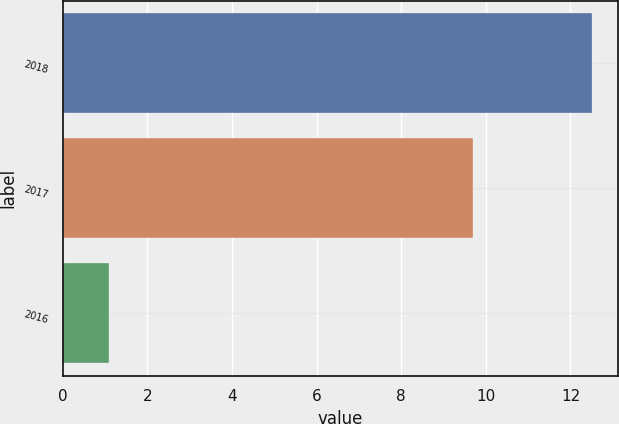Convert chart to OTSL. <chart><loc_0><loc_0><loc_500><loc_500><bar_chart><fcel>2018<fcel>2017<fcel>2016<nl><fcel>12.5<fcel>9.7<fcel>1.1<nl></chart> 